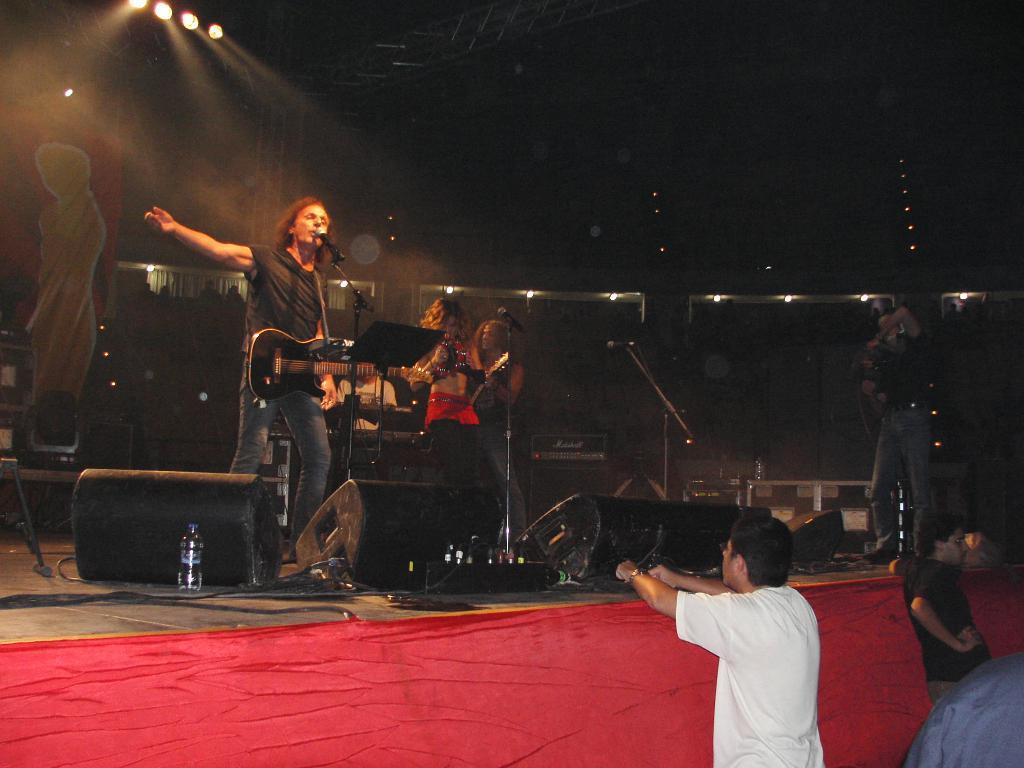How would you summarize this image in a sentence or two? This picture describes about group of people, few people are musical instruments in front of the microphone on the stage, in the background we can see a hoarding and couple of lights. 